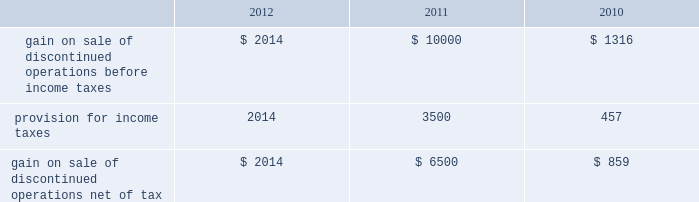Analog devices , inc .
Notes to consolidated financial statements 2014 ( continued ) asu no .
2011-05 is effective for fiscal years , and interim periods within those years , beginning after december 15 , 2011 , which is the company 2019s fiscal year 2013 .
Subsequently , in december 2011 , the fasb issued asu no .
2011-12 , deferral of the effective date for amendments to the presentation of reclassifications of items out of accumulated other comprehensive income in accounting standards update no .
2011-05 ( asu no .
2011-12 ) , which defers only those changes in asu no .
2011-05 that relate to the presentation of reclassification adjustments but does not affect all other requirements in asu no .
2011-05 .
The adoption of asu no .
2011-05 and asu no .
2011-12 will affect the presentation of comprehensive income but will not materially impact the company 2019s financial condition or results of operations .
Discontinued operations in november 2007 , the company entered into a purchase and sale agreement with certain subsidiaries of on semiconductor corporation to sell the company 2019s cpu voltage regulation and pc thermal monitoring business which consisted of core voltage regulator products for the central processing unit in computing and gaming applications and temperature sensors and fan-speed controllers for managing the temperature of the central processing unit .
During fiscal 2008 , the company completed the sale of this business .
In the first quarter of fiscal 2010 , proceeds of $ 1 million were released from escrow and $ 0.6 million net of tax was recorded as additional gain from the sale of discontinued operations .
The company does not expect any additional proceeds from this sale .
In september 2007 , the company entered into a definitive agreement to sell its baseband chipset business to mediatek inc .
The decision to sell the baseband chipset business was due to the company 2019s decision to focus its resources in areas where its signal processing expertise can provide unique capabilities and earn superior returns .
During fiscal 2008 , the company completed the sale of its baseband chipset business for net cash proceeds of $ 269 million .
The company made cash payments of $ 1.7 million during fiscal 2009 related to retention payments for employees who transferred to mediatek inc .
And for the reimbursement of intellectual property license fees incurred by mediatek .
During fiscal 2010 , the company received cash proceeds of $ 62 million as a result of the receipt of a refundable withholding tax and also recorded an additional gain on sale of $ 0.3 million , or $ 0.2 million net of tax , due to the settlement of certain items at less than the amounts accrued .
In fiscal 2011 , additional proceeds of $ 10 million were released from escrow and $ 6.5 million net of tax was recorded as additional gain from the sale of discontinued operations .
The company does not expect any additional proceeds from this sale .
The following amounts related to the cpu voltage regulation and pc thermal monitoring and baseband chipset businesses have been segregated from continuing operations and reported as discontinued operations. .
Stock-based compensation and shareholders 2019 equity equity compensation plans the company grants , or has granted , stock options and other stock and stock-based awards under the 2006 stock incentive plan ( 2006 plan ) .
The 2006 plan was approved by the company 2019s board of directors on january 23 , 2006 and was approved by shareholders on march 14 , 2006 and subsequently amended in march 2006 , june 2009 , september 2009 , december 2009 , december 2010 and june 2011 .
The 2006 plan provides for the grant of up to 15 million shares of the company 2019s common stock , plus such number of additional shares that were subject to outstanding options under the company 2019s previous plans that are not issued because the applicable option award subsequently terminates or expires without being exercised .
The 2006 plan provides for the grant of incentive stock options intended to qualify under section 422 of the internal revenue code of 1986 , as amended , non-statutory stock options , stock appreciation rights , restricted stock , restricted stock units and other stock-based awards .
Employees , officers , directors , consultants and advisors of the company and its subsidiaries are eligible to be granted awards under the 2006 plan .
No award may be made under the 2006 plan after march 13 , 2016 , but awards previously granted may extend beyond that date .
The company will not grant further options under any previous plans .
While the company may grant to employees options that become exercisable at different times or within different periods , the company has generally granted to employees options that vest over five years and become exercisable in annual installments of 20% ( 20 % ) on each of the first , second , third , fourth and fifth anniversaries of the date of grant ; 33.3% ( 33.3 % ) on each of the third , fourth , and fifth anniversaries of the date of grant ; or in annual installments of 25% ( 25 % ) on each of the second , third , fourth .
What is the effective income tax rate in 2010 based on the information about the gains on sales of discontinued operations? 
Computations: (457 / 1316)
Answer: 0.34726. 